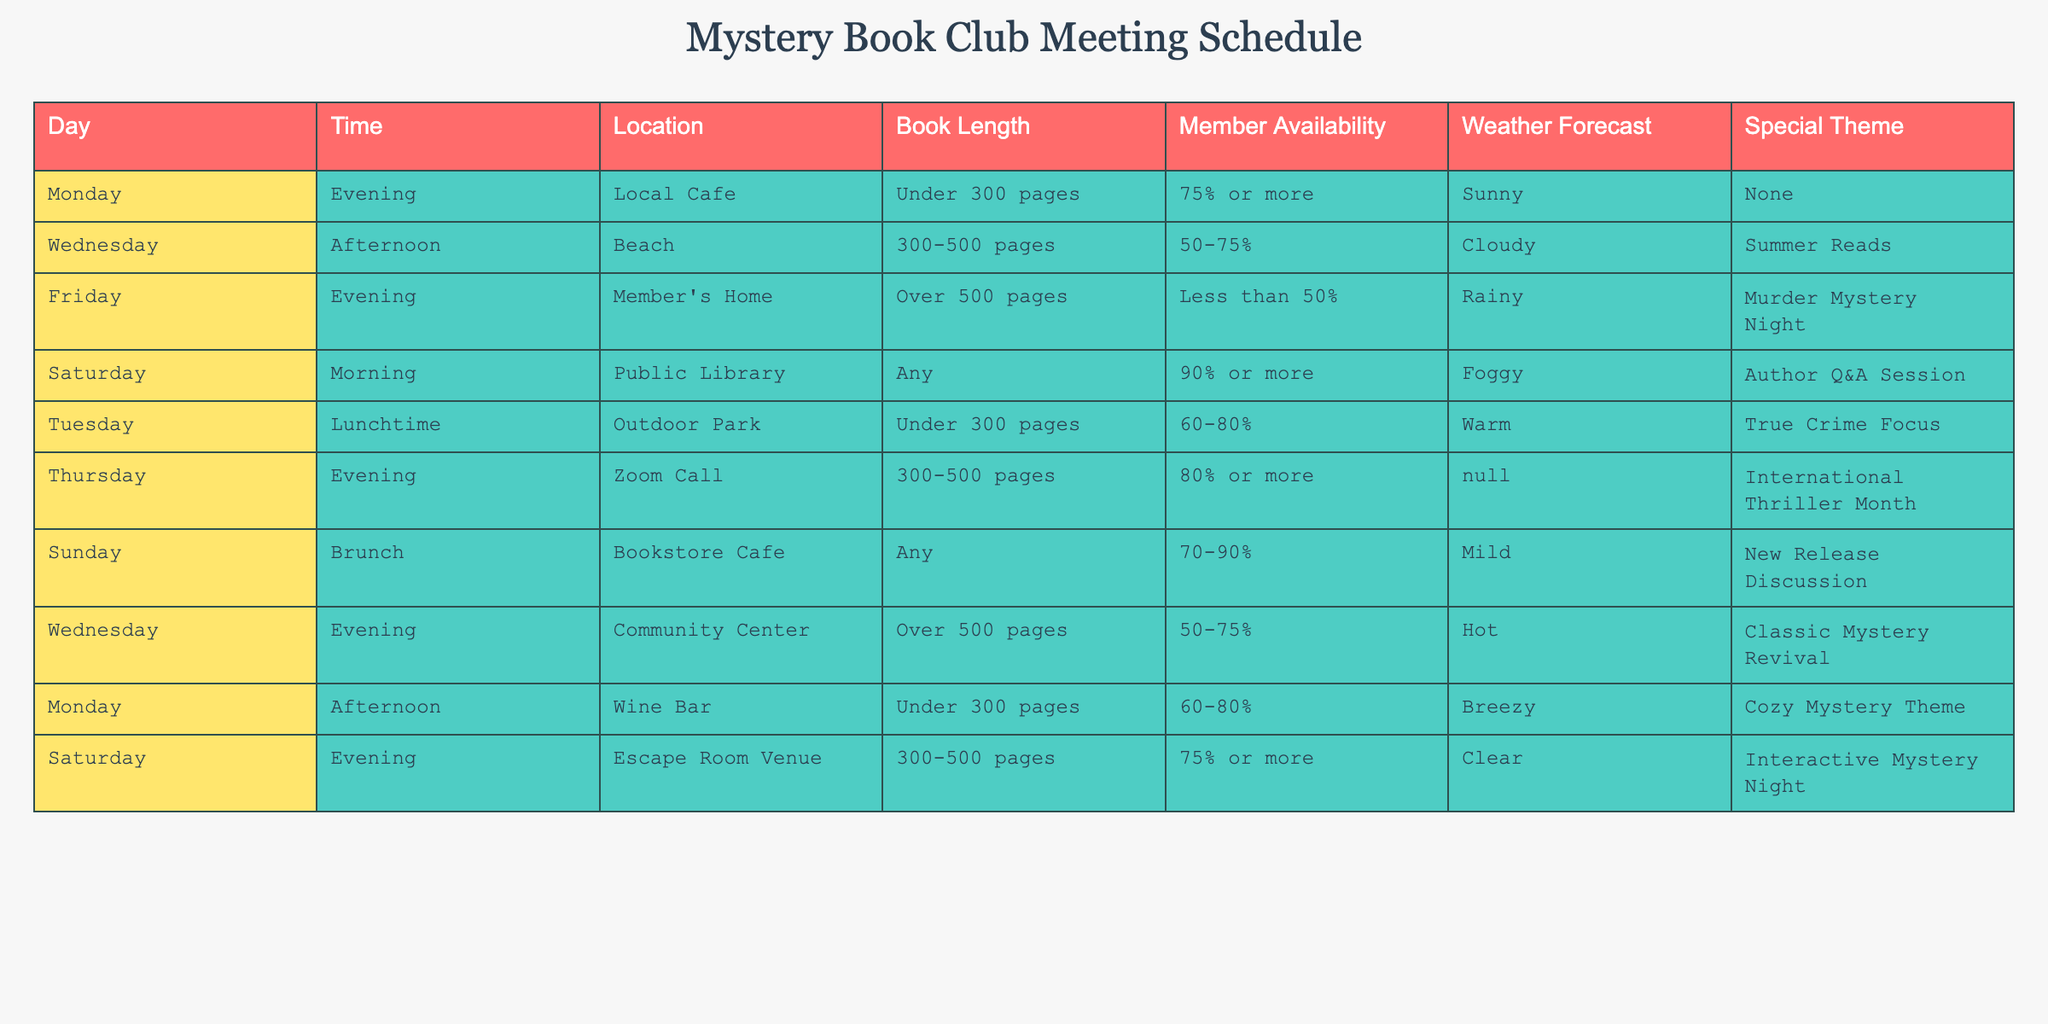What is the location for the Saturday morning meeting? The table lists the Saturday morning meeting location as "Public Library."
Answer: Public Library How many meetings have a special theme of a "Murder Mystery Night"? The table shows one meeting scheduled for "Murder Mystery Night" on Friday evening.
Answer: 1 What percentage of members are available for the Monday afternoon meeting? The table indicates that for the Monday afternoon meeting at the Wine Bar, member availability is noted as "60-80%."
Answer: 60-80% Is there any meeting on a Tuesday, and if so, what is the weather forecast for that day? The table includes a meeting on Tuesday at Outdoor Park, with the weather forecast listed as "Warm."
Answer: Yes, Warm For meetings with books over 500 pages, which day has a special theme? In the table, the Wednesday evening meeting at the Community Center has a special theme of "Classic Mystery Revival" for books over 500 pages.
Answer: Wednesday How many total meetings are there in the table? Upon reviewing the table, there are a total of 10 entries indicating meetings scheduled.
Answer: 10 What is the average member availability percentage for the meetings listed? The member availability percentages can be extracted: 75%, 62.5% (average of 50 and 75), 25%, 90%, 70%, 80%, 75%, 60%, and 70%. Their sum is 637.5%, and dividing by 10 gives an average of 63.75%.
Answer: 63.75% On which day is there a meeting that is both "Foggy" and requires less than 50% member availability? Referring to the table, no meeting satisfies both conditions: "Foggy" meetings are on Saturday morning, while the only meeting with less than 50% availability is on Friday evening.
Answer: No meetings match Which meetings take place in the evening? The table lists meetings on Monday, Friday, Wednesday, and Thursday as all occurring in the evening.
Answer: Monday, Friday, Wednesday, Thursday 